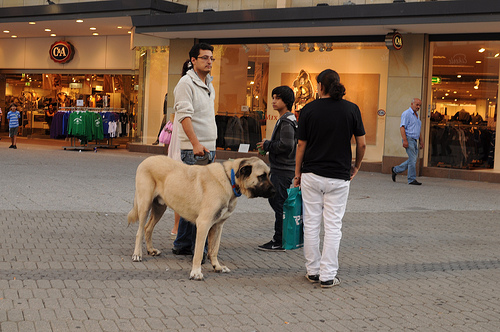Is the jacket gray? Yes, the jacket is gray, providing a neutral yet stylish choice for outdoor wear. 